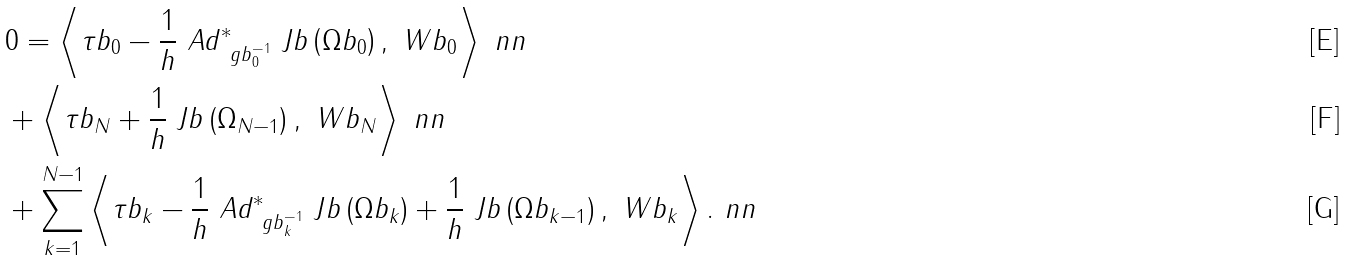<formula> <loc_0><loc_0><loc_500><loc_500>& 0 = \left < \tau b _ { 0 } - \frac { 1 } { h } \ A d _ { \ g b _ { 0 } ^ { - 1 } } ^ { * } \ J b \left ( \Omega b _ { 0 } \right ) , \ W b _ { 0 } \right > \ n n \\ & + \left < \tau b _ { N } + \frac { 1 } { h } \ J b \left ( \Omega _ { N - 1 } \right ) , \ W b _ { N } \right > \ n n \\ & + \sum _ { k = 1 } ^ { N - 1 } \left < \tau b _ { k } - \frac { 1 } { h } \ A d _ { \ g b _ { k } ^ { - 1 } } ^ { * } \ J b \left ( \Omega b _ { k } \right ) + \frac { 1 } { h } \ J b \left ( \Omega b _ { k - 1 } \right ) , \ W b _ { k } \right > . \ n n</formula> 